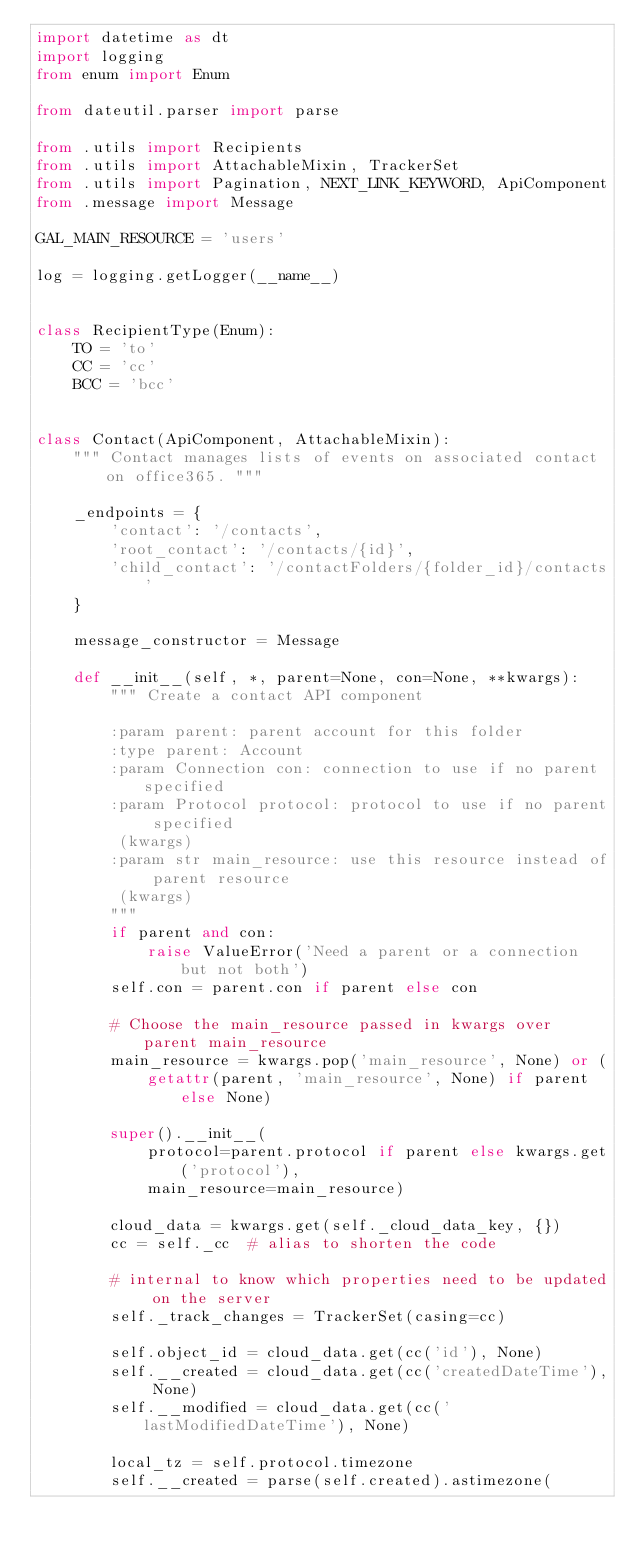<code> <loc_0><loc_0><loc_500><loc_500><_Python_>import datetime as dt
import logging
from enum import Enum

from dateutil.parser import parse

from .utils import Recipients
from .utils import AttachableMixin, TrackerSet
from .utils import Pagination, NEXT_LINK_KEYWORD, ApiComponent
from .message import Message

GAL_MAIN_RESOURCE = 'users'

log = logging.getLogger(__name__)


class RecipientType(Enum):
    TO = 'to'
    CC = 'cc'
    BCC = 'bcc'


class Contact(ApiComponent, AttachableMixin):
    """ Contact manages lists of events on associated contact on office365. """

    _endpoints = {
        'contact': '/contacts',
        'root_contact': '/contacts/{id}',
        'child_contact': '/contactFolders/{folder_id}/contacts'
    }

    message_constructor = Message

    def __init__(self, *, parent=None, con=None, **kwargs):
        """ Create a contact API component

        :param parent: parent account for this folder
        :type parent: Account
        :param Connection con: connection to use if no parent specified
        :param Protocol protocol: protocol to use if no parent specified
         (kwargs)
        :param str main_resource: use this resource instead of parent resource
         (kwargs)
        """
        if parent and con:
            raise ValueError('Need a parent or a connection but not both')
        self.con = parent.con if parent else con

        # Choose the main_resource passed in kwargs over parent main_resource
        main_resource = kwargs.pop('main_resource', None) or (
            getattr(parent, 'main_resource', None) if parent else None)

        super().__init__(
            protocol=parent.protocol if parent else kwargs.get('protocol'),
            main_resource=main_resource)

        cloud_data = kwargs.get(self._cloud_data_key, {})
        cc = self._cc  # alias to shorten the code

        # internal to know which properties need to be updated on the server
        self._track_changes = TrackerSet(casing=cc)

        self.object_id = cloud_data.get(cc('id'), None)
        self.__created = cloud_data.get(cc('createdDateTime'), None)
        self.__modified = cloud_data.get(cc('lastModifiedDateTime'), None)

        local_tz = self.protocol.timezone
        self.__created = parse(self.created).astimezone(</code> 